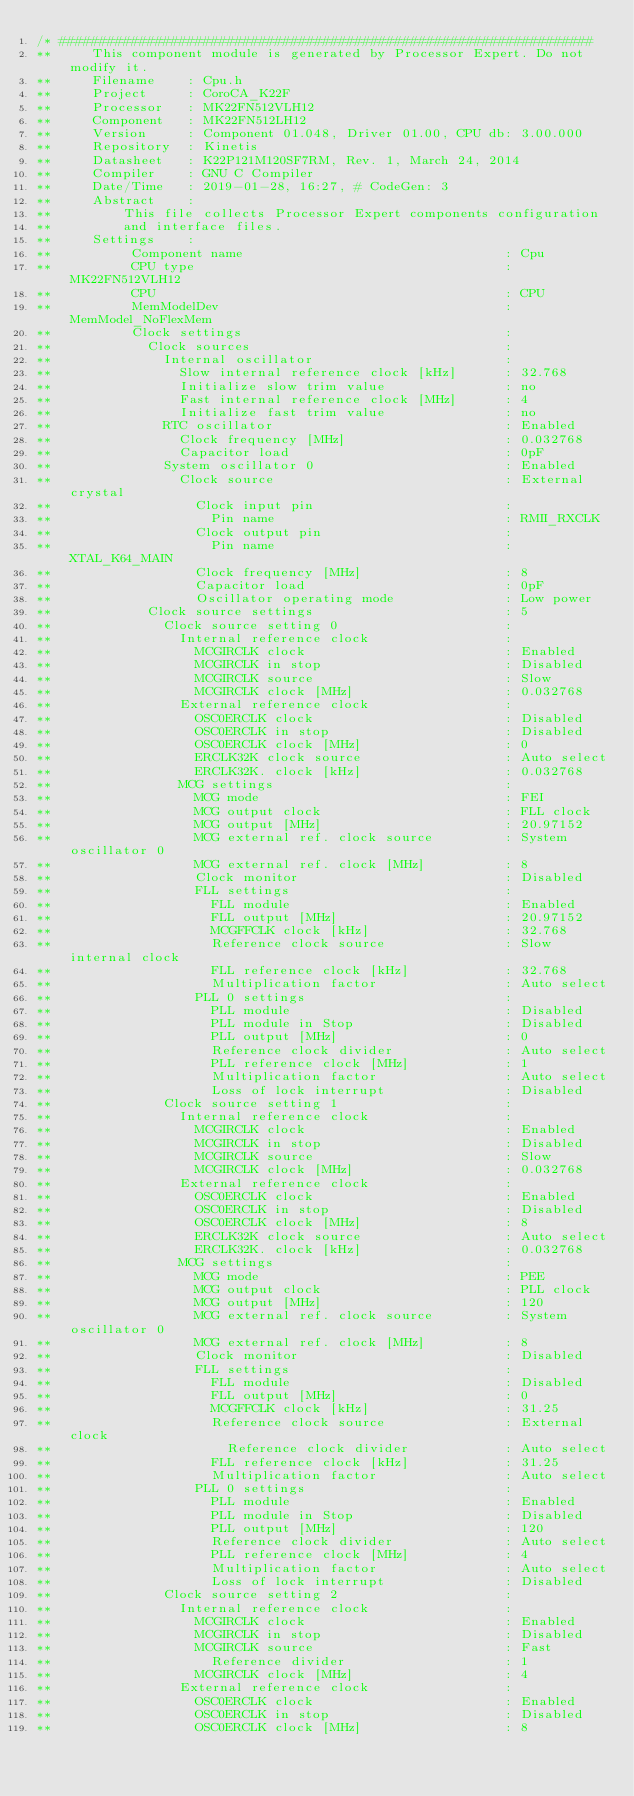Convert code to text. <code><loc_0><loc_0><loc_500><loc_500><_C_>/* ###################################################################
**     This component module is generated by Processor Expert. Do not modify it.
**     Filename    : Cpu.h
**     Project     : CoroCA_K22F
**     Processor   : MK22FN512VLH12
**     Component   : MK22FN512LH12
**     Version     : Component 01.048, Driver 01.00, CPU db: 3.00.000
**     Repository  : Kinetis
**     Datasheet   : K22P121M120SF7RM, Rev. 1, March 24, 2014
**     Compiler    : GNU C Compiler
**     Date/Time   : 2019-01-28, 16:27, # CodeGen: 3
**     Abstract    :
**         This file collects Processor Expert components configuration 
**         and interface files.
**     Settings    :
**          Component name                                 : Cpu
**          CPU type                                       : MK22FN512VLH12
**          CPU                                            : CPU
**          MemModelDev                                    : MemModel_NoFlexMem
**          Clock settings                                 : 
**            Clock sources                                : 
**              Internal oscillator                        : 
**                Slow internal reference clock [kHz]      : 32.768
**                Initialize slow trim value               : no
**                Fast internal reference clock [MHz]      : 4
**                Initialize fast trim value               : no
**              RTC oscillator                             : Enabled
**                Clock frequency [MHz]                    : 0.032768
**                Capacitor load                           : 0pF
**              System oscillator 0                        : Enabled
**                Clock source                             : External crystal
**                  Clock input pin                        : 
**                    Pin name                             : RMII_RXCLK
**                  Clock output pin                       : 
**                    Pin name                             : XTAL_K64_MAIN
**                  Clock frequency [MHz]                  : 8
**                  Capacitor load                         : 0pF
**                  Oscillator operating mode              : Low power
**            Clock source settings                        : 5
**              Clock source setting 0                     : 
**                Internal reference clock                 : 
**                  MCGIRCLK clock                         : Enabled
**                  MCGIRCLK in stop                       : Disabled
**                  MCGIRCLK source                        : Slow
**                  MCGIRCLK clock [MHz]                   : 0.032768
**                External reference clock                 : 
**                  OSC0ERCLK clock                        : Disabled
**                  OSC0ERCLK in stop                      : Disabled
**                  OSC0ERCLK clock [MHz]                  : 0
**                  ERCLK32K clock source                  : Auto select
**                  ERCLK32K. clock [kHz]                  : 0.032768
**                MCG settings                             : 
**                  MCG mode                               : FEI
**                  MCG output clock                       : FLL clock
**                  MCG output [MHz]                       : 20.97152
**                  MCG external ref. clock source         : System oscillator 0
**                  MCG external ref. clock [MHz]          : 8
**                  Clock monitor                          : Disabled
**                  FLL settings                           : 
**                    FLL module                           : Enabled
**                    FLL output [MHz]                     : 20.97152
**                    MCGFFCLK clock [kHz]                 : 32.768
**                    Reference clock source               : Slow internal clock
**                    FLL reference clock [kHz]            : 32.768
**                    Multiplication factor                : Auto select
**                  PLL 0 settings                         : 
**                    PLL module                           : Disabled
**                    PLL module in Stop                   : Disabled
**                    PLL output [MHz]                     : 0
**                    Reference clock divider              : Auto select
**                    PLL reference clock [MHz]            : 1
**                    Multiplication factor                : Auto select
**                    Loss of lock interrupt               : Disabled
**              Clock source setting 1                     : 
**                Internal reference clock                 : 
**                  MCGIRCLK clock                         : Enabled
**                  MCGIRCLK in stop                       : Disabled
**                  MCGIRCLK source                        : Slow
**                  MCGIRCLK clock [MHz]                   : 0.032768
**                External reference clock                 : 
**                  OSC0ERCLK clock                        : Enabled
**                  OSC0ERCLK in stop                      : Disabled
**                  OSC0ERCLK clock [MHz]                  : 8
**                  ERCLK32K clock source                  : Auto select
**                  ERCLK32K. clock [kHz]                  : 0.032768
**                MCG settings                             : 
**                  MCG mode                               : PEE
**                  MCG output clock                       : PLL clock
**                  MCG output [MHz]                       : 120
**                  MCG external ref. clock source         : System oscillator 0
**                  MCG external ref. clock [MHz]          : 8
**                  Clock monitor                          : Disabled
**                  FLL settings                           : 
**                    FLL module                           : Disabled
**                    FLL output [MHz]                     : 0
**                    MCGFFCLK clock [kHz]                 : 31.25
**                    Reference clock source               : External clock
**                      Reference clock divider            : Auto select
**                    FLL reference clock [kHz]            : 31.25
**                    Multiplication factor                : Auto select
**                  PLL 0 settings                         : 
**                    PLL module                           : Enabled
**                    PLL module in Stop                   : Disabled
**                    PLL output [MHz]                     : 120
**                    Reference clock divider              : Auto select
**                    PLL reference clock [MHz]            : 4
**                    Multiplication factor                : Auto select
**                    Loss of lock interrupt               : Disabled
**              Clock source setting 2                     : 
**                Internal reference clock                 : 
**                  MCGIRCLK clock                         : Enabled
**                  MCGIRCLK in stop                       : Disabled
**                  MCGIRCLK source                        : Fast
**                    Reference divider                    : 1
**                  MCGIRCLK clock [MHz]                   : 4
**                External reference clock                 : 
**                  OSC0ERCLK clock                        : Enabled
**                  OSC0ERCLK in stop                      : Disabled
**                  OSC0ERCLK clock [MHz]                  : 8</code> 